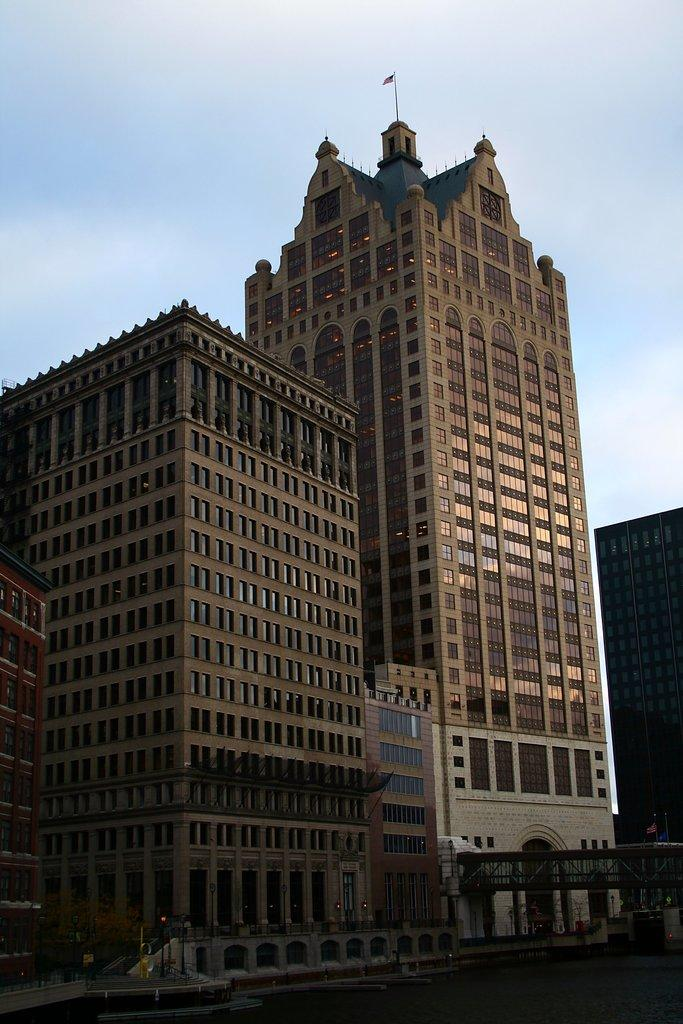What structures are present in the image? There are buildings in the image. What can be seen in the sky in the image? The sky is visible at the top of the image and appears to be clear. Is there any wilderness visible in the image? There is no wilderness present in the image; it features buildings and a clear sky. Can you see any ice in the image? There is no ice visible in the image. 